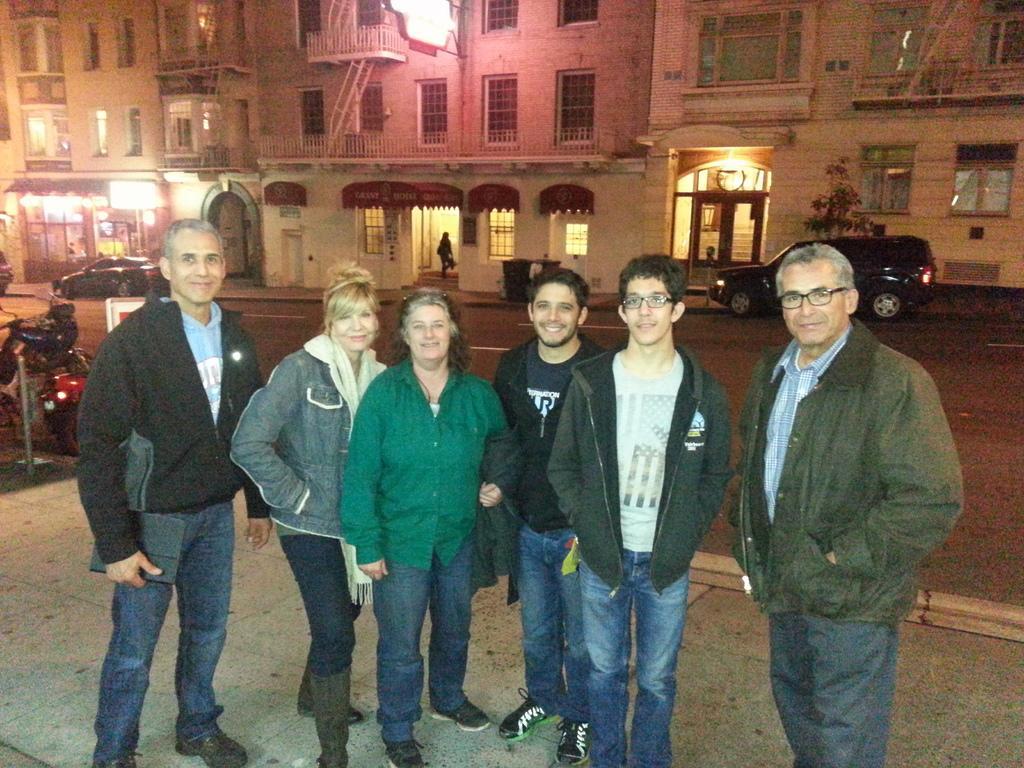How would you summarize this image in a sentence or two? In this picture there are group of people standing on the footpath and smiling. At the back there are vehicles on the road. At the back there is a building and there is a plant of the footpath. There is a person walking inside the building and there is a hoarding on the building. On the left side of the image there is a pole on the footpath. 